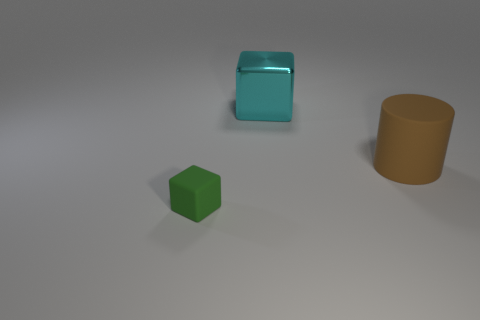If these objects had a physical texture, how would you describe them just by looking? Judging by their appearance, the green cube would likely have a matte texture as it doesn't reflect light. The cyan cube, with its shiny appearance, would probably feel smooth and maybe even slightly slippery due to its reflective surface. The brown cylinder's texture isn't clearly visible, but its lack of shine suggests a matte, possibly rougher texture than the cyan cube. 